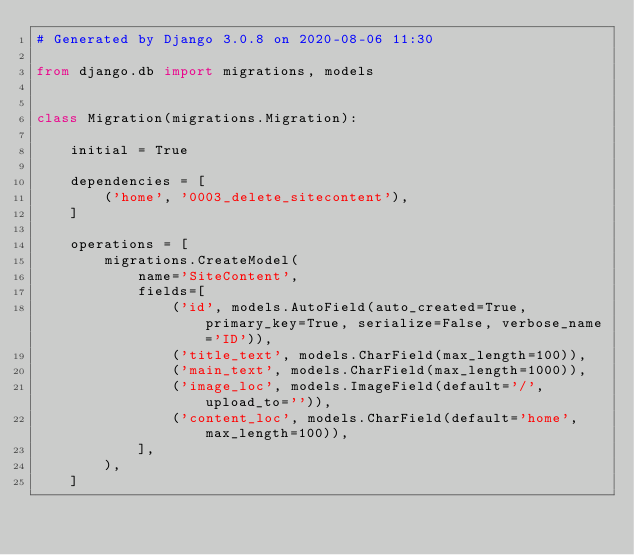<code> <loc_0><loc_0><loc_500><loc_500><_Python_># Generated by Django 3.0.8 on 2020-08-06 11:30

from django.db import migrations, models


class Migration(migrations.Migration):

    initial = True

    dependencies = [
        ('home', '0003_delete_sitecontent'),
    ]

    operations = [
        migrations.CreateModel(
            name='SiteContent',
            fields=[
                ('id', models.AutoField(auto_created=True, primary_key=True, serialize=False, verbose_name='ID')),
                ('title_text', models.CharField(max_length=100)),
                ('main_text', models.CharField(max_length=1000)),
                ('image_loc', models.ImageField(default='/', upload_to='')),
                ('content_loc', models.CharField(default='home', max_length=100)),
            ],
        ),
    ]
</code> 